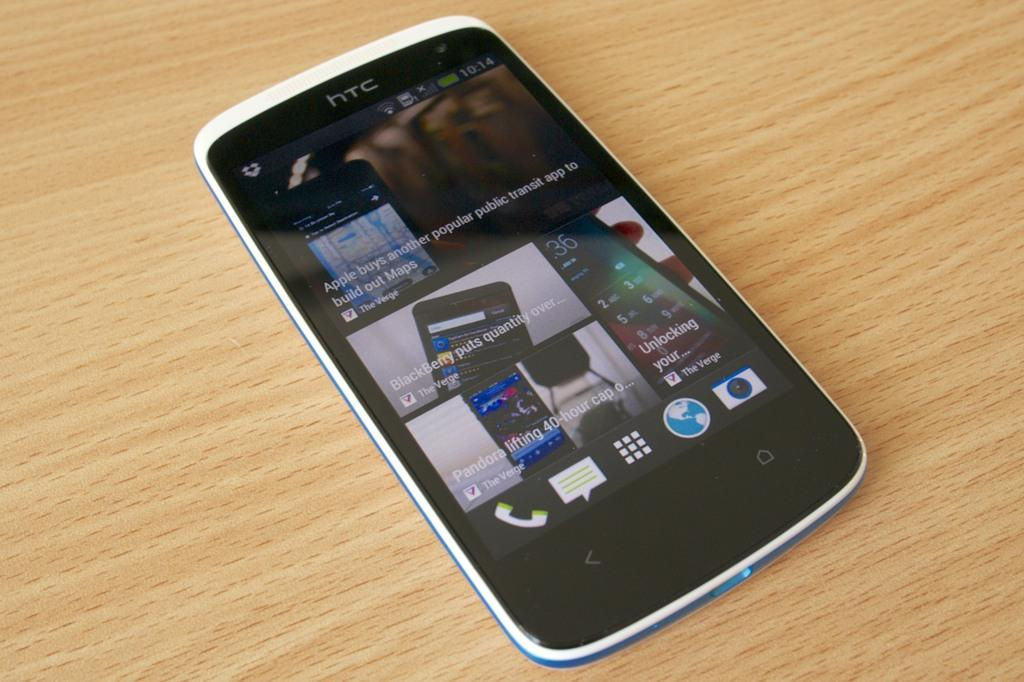What type of furniture is present in the image? There is a table in the image. What object can be seen on the table? There is a mobile phone on the table. What type of doll is sitting on the kettle in the image? There is no doll or kettle present in the image. 